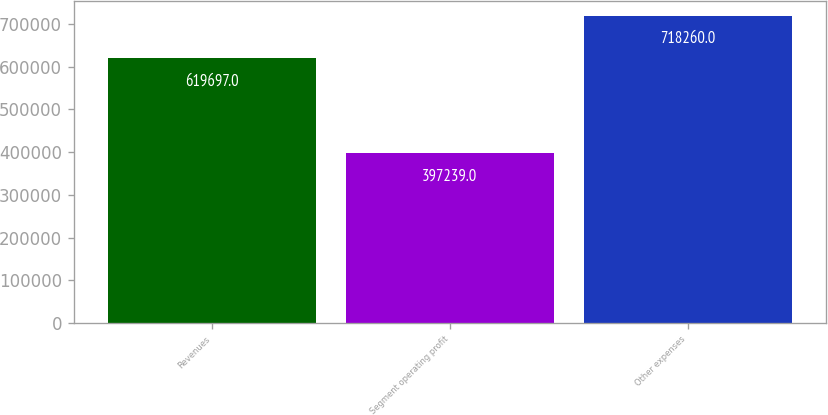<chart> <loc_0><loc_0><loc_500><loc_500><bar_chart><fcel>Revenues<fcel>Segment operating profit<fcel>Other expenses<nl><fcel>619697<fcel>397239<fcel>718260<nl></chart> 